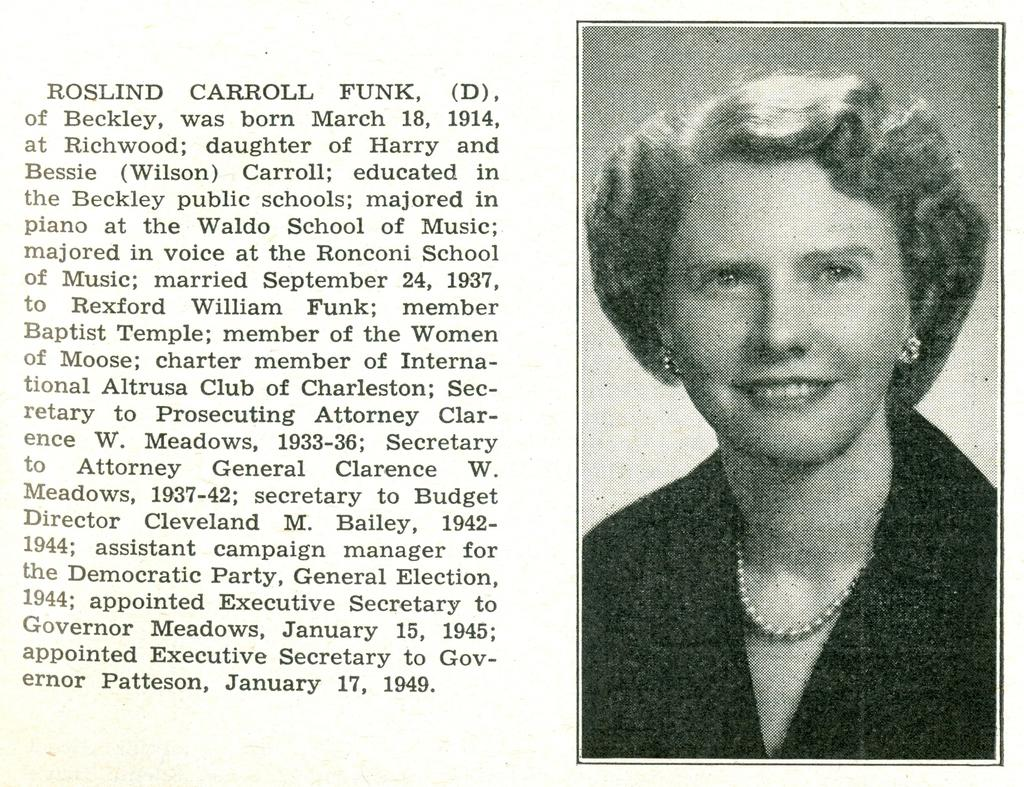What is the main object in the image? There is a paper in the image. What can be seen on the right side of the paper? The paper has a picture of a woman on the right side. What is written on the left side of the paper? There is a paragraph written on the left side of the paper. What type of prison is depicted in the image? There is no prison present in the image; it features a paper with a picture of a woman and a paragraph. 